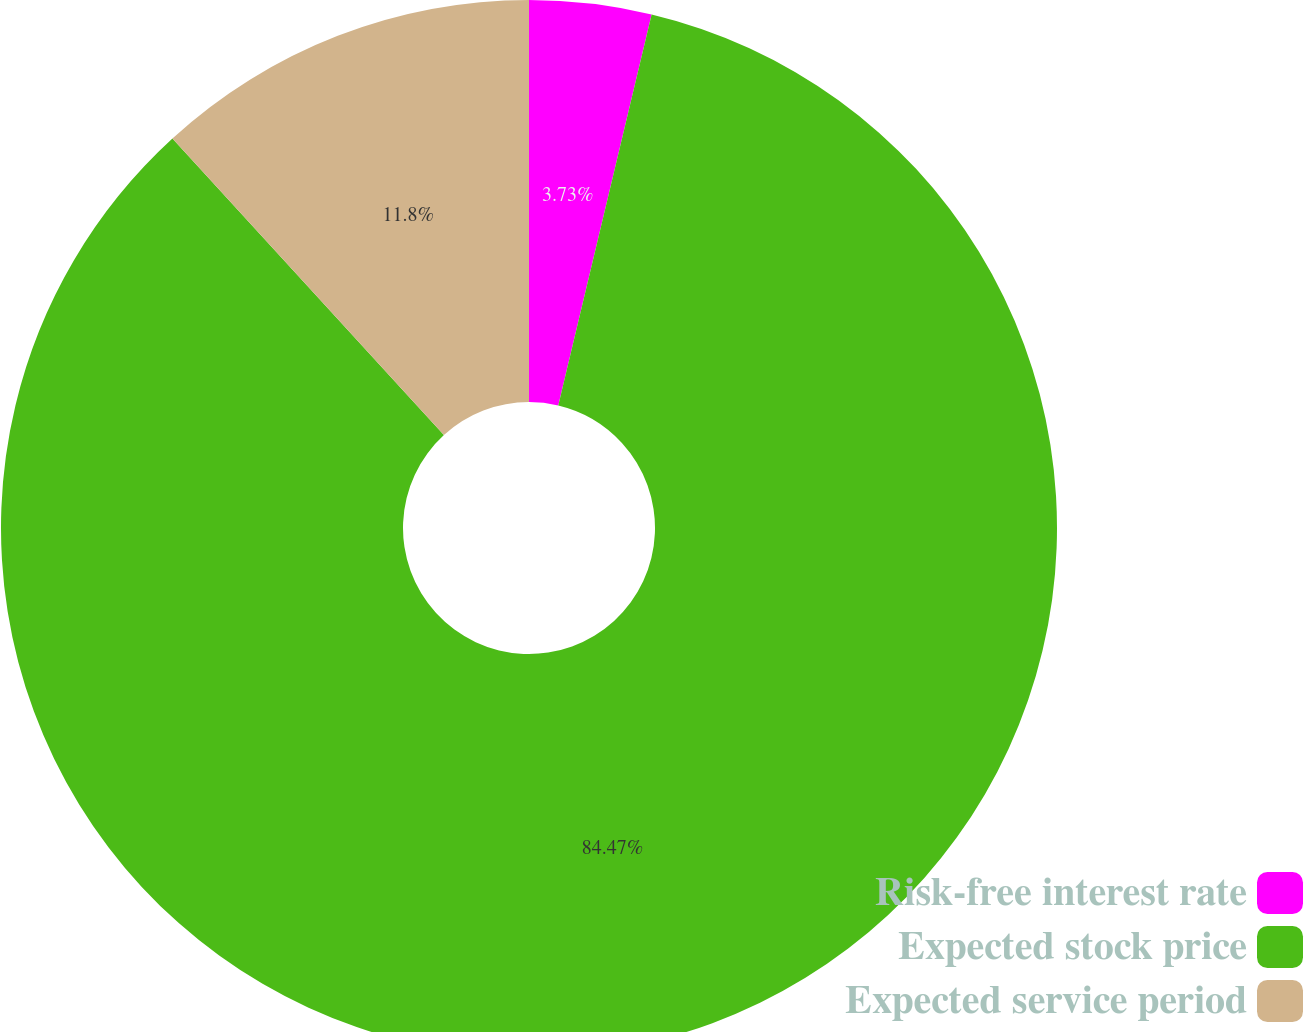<chart> <loc_0><loc_0><loc_500><loc_500><pie_chart><fcel>Risk-free interest rate<fcel>Expected stock price<fcel>Expected service period<nl><fcel>3.73%<fcel>84.47%<fcel>11.8%<nl></chart> 